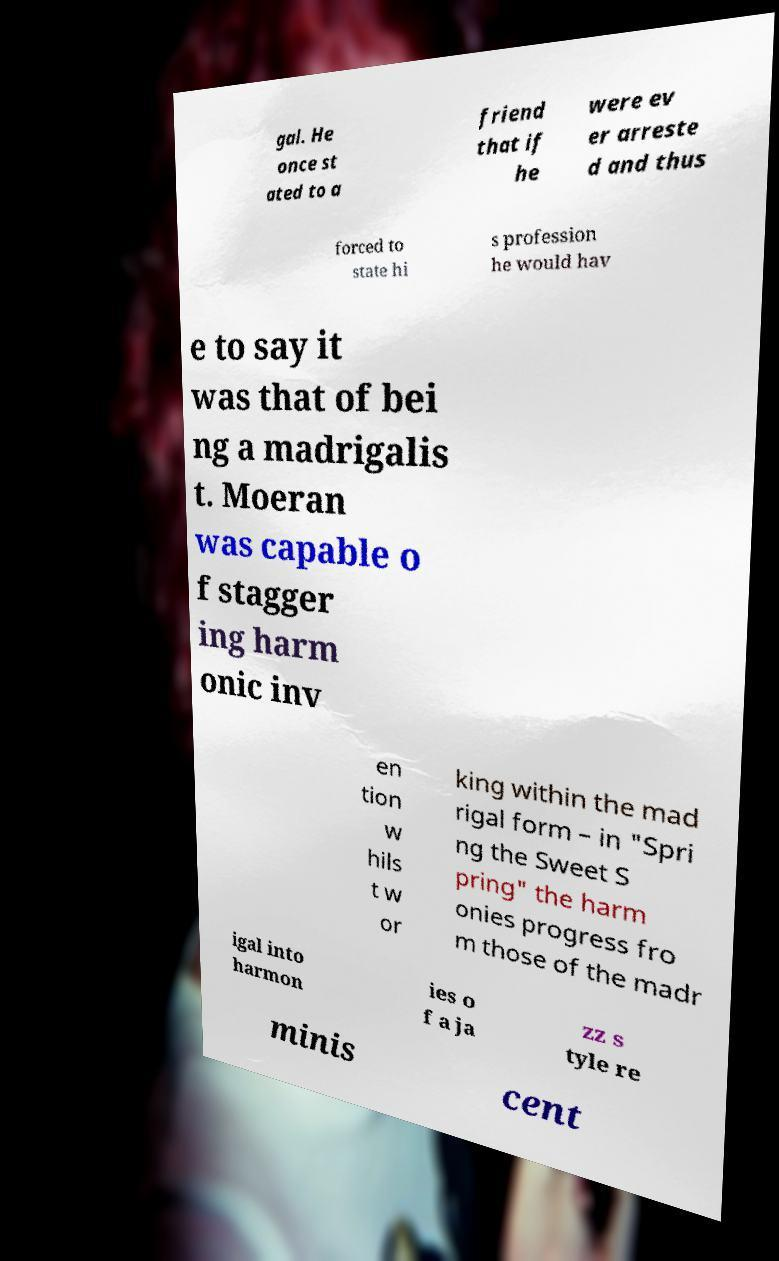There's text embedded in this image that I need extracted. Can you transcribe it verbatim? gal. He once st ated to a friend that if he were ev er arreste d and thus forced to state hi s profession he would hav e to say it was that of bei ng a madrigalis t. Moeran was capable o f stagger ing harm onic inv en tion w hils t w or king within the mad rigal form – in "Spri ng the Sweet S pring" the harm onies progress fro m those of the madr igal into harmon ies o f a ja zz s tyle re minis cent 